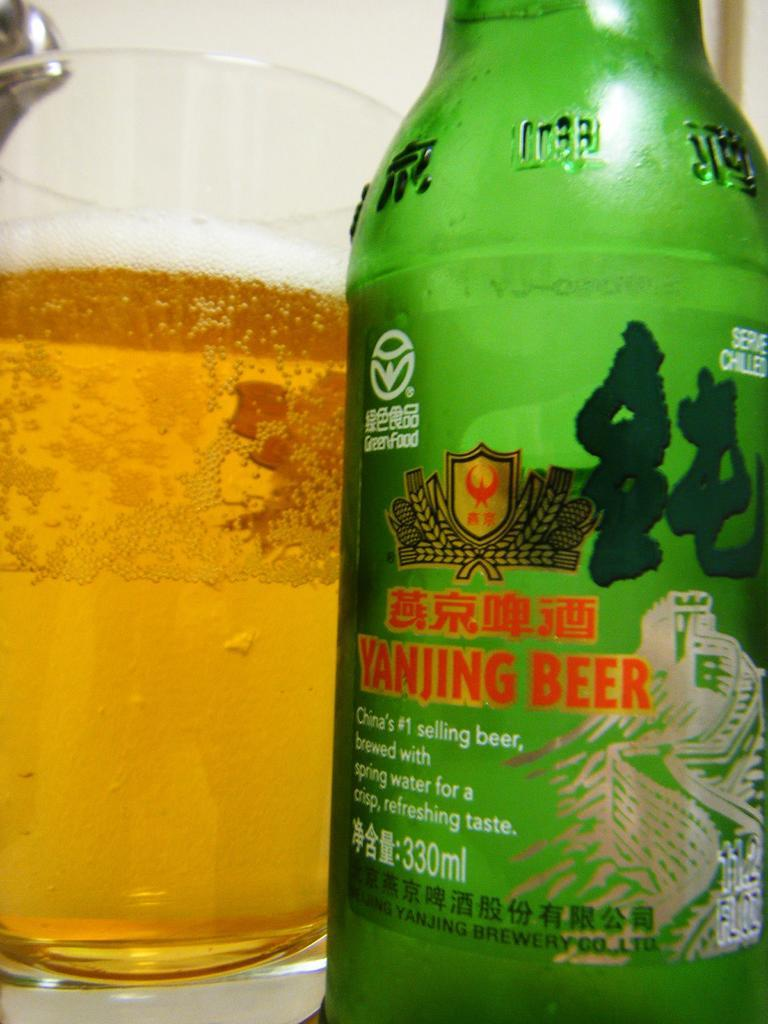What is inside the glass that is visible in the image? There is a glass with liquid in the image. What is inside the liquid in the glass? There is a bottle inside the glass. What can be seen on the bottle? The bottle has a sticker on it. What industry is depicted in the title of the image? There is no title present in the image, and therefore no industry can be associated with it. 